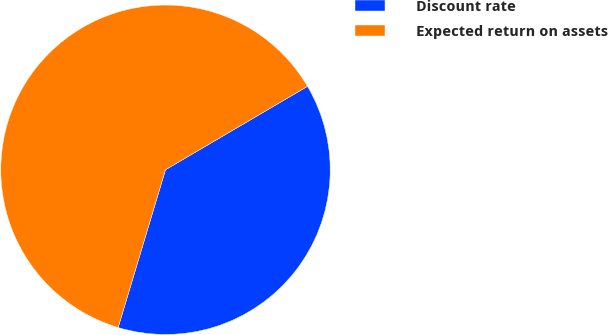Convert chart to OTSL. <chart><loc_0><loc_0><loc_500><loc_500><pie_chart><fcel>Discount rate<fcel>Expected return on assets<nl><fcel>38.09%<fcel>61.91%<nl></chart> 